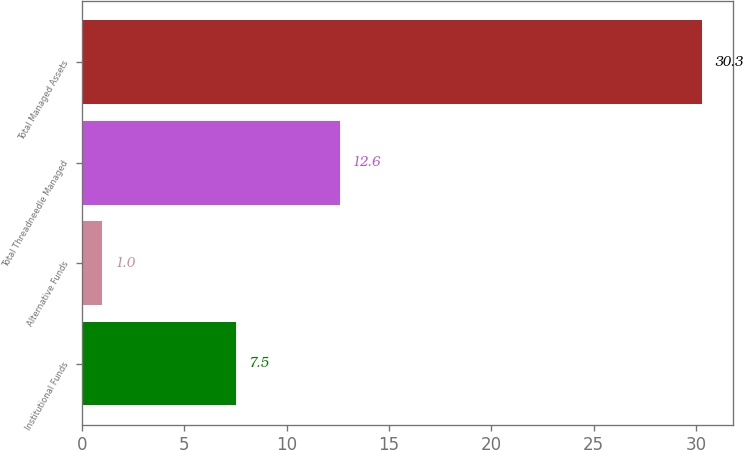Convert chart to OTSL. <chart><loc_0><loc_0><loc_500><loc_500><bar_chart><fcel>Institutional Funds<fcel>Alternative Funds<fcel>Total Threadneedle Managed<fcel>Total Managed Assets<nl><fcel>7.5<fcel>1<fcel>12.6<fcel>30.3<nl></chart> 